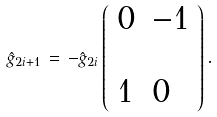<formula> <loc_0><loc_0><loc_500><loc_500>\hat { g } _ { 2 i + 1 } \, = \, - \hat { g } _ { 2 i } \left ( \begin{array} { l l } { 0 } & { - 1 } \\ \\ { 1 } & { 0 } \end{array} \right ) .</formula> 